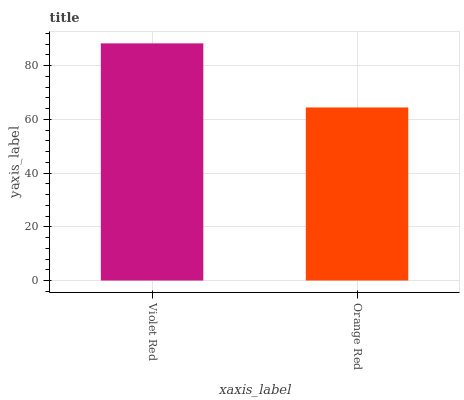Is Violet Red the maximum?
Answer yes or no. Yes. Is Orange Red the maximum?
Answer yes or no. No. Is Violet Red greater than Orange Red?
Answer yes or no. Yes. Is Orange Red less than Violet Red?
Answer yes or no. Yes. Is Orange Red greater than Violet Red?
Answer yes or no. No. Is Violet Red less than Orange Red?
Answer yes or no. No. Is Violet Red the high median?
Answer yes or no. Yes. Is Orange Red the low median?
Answer yes or no. Yes. Is Orange Red the high median?
Answer yes or no. No. Is Violet Red the low median?
Answer yes or no. No. 